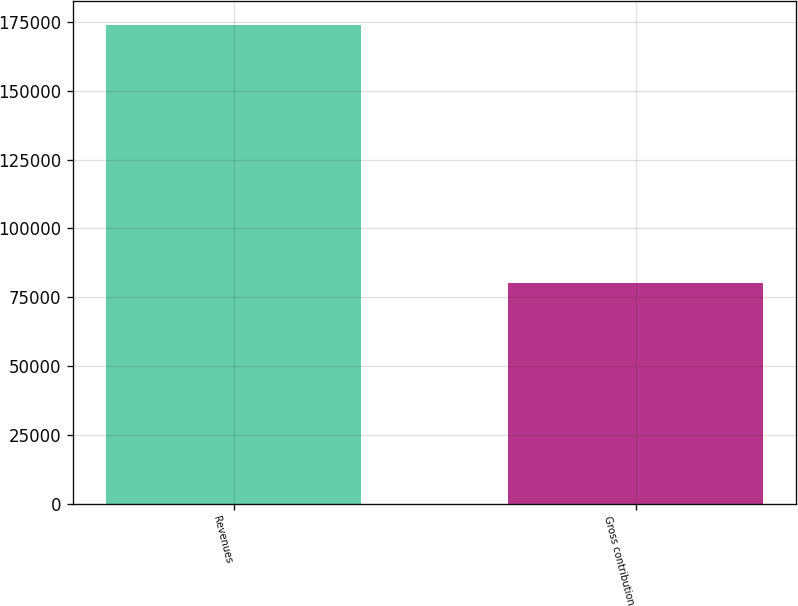Convert chart. <chart><loc_0><loc_0><loc_500><loc_500><bar_chart><fcel>Revenues<fcel>Gross contribution<nl><fcel>173768<fcel>80119<nl></chart> 